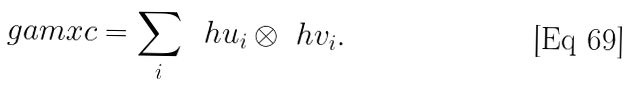Convert formula to latex. <formula><loc_0><loc_0><loc_500><loc_500>\ g a m x c = \sum _ { i } \, \ h u _ { i } \otimes \ h v _ { i } .</formula> 